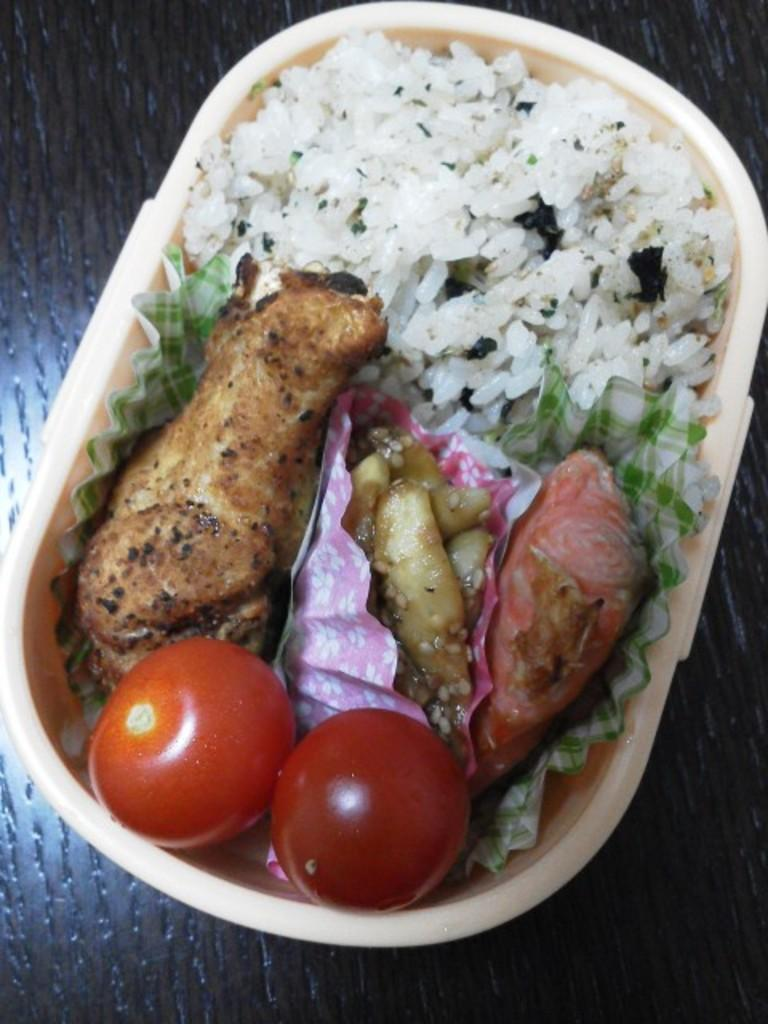What is inside the box that is visible in the image? There is a box with tomatoes in the image. What type of food can be seen in the image? There is food in the image, specifically tomatoes. What else is present in the image besides food? There are papers in the image. On what surface are the objects placed in the image? The objects are on a wooden platform. How many sisters are sitting on the wooden platform in the image? There are no sisters present in the image; it only features a box of tomatoes, papers, and a wooden platform. 